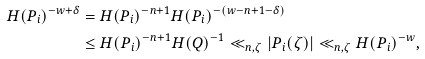Convert formula to latex. <formula><loc_0><loc_0><loc_500><loc_500>H ( P _ { i } ) ^ { - w + \delta } & = H ( P _ { i } ) ^ { - n + 1 } H ( P _ { i } ) ^ { - ( w - n + 1 - \delta ) } \\ & \leq H ( P _ { i } ) ^ { - n + 1 } H ( Q ) ^ { - 1 } \ll _ { n , \zeta } | P _ { i } ( \zeta ) | \ll _ { n , \zeta } H ( P _ { i } ) ^ { - w } ,</formula> 